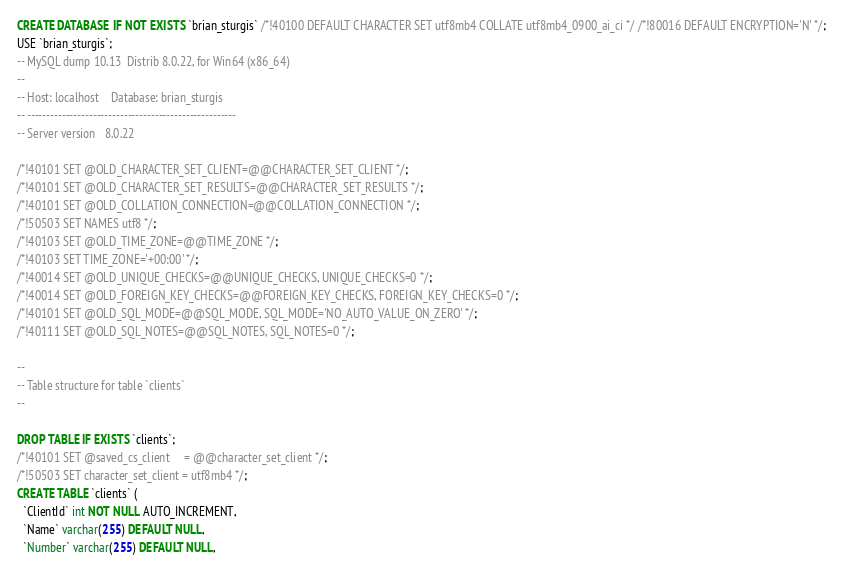Convert code to text. <code><loc_0><loc_0><loc_500><loc_500><_SQL_>CREATE DATABASE  IF NOT EXISTS `brian_sturgis` /*!40100 DEFAULT CHARACTER SET utf8mb4 COLLATE utf8mb4_0900_ai_ci */ /*!80016 DEFAULT ENCRYPTION='N' */;
USE `brian_sturgis`;
-- MySQL dump 10.13  Distrib 8.0.22, for Win64 (x86_64)
--
-- Host: localhost    Database: brian_sturgis
-- ------------------------------------------------------
-- Server version	8.0.22

/*!40101 SET @OLD_CHARACTER_SET_CLIENT=@@CHARACTER_SET_CLIENT */;
/*!40101 SET @OLD_CHARACTER_SET_RESULTS=@@CHARACTER_SET_RESULTS */;
/*!40101 SET @OLD_COLLATION_CONNECTION=@@COLLATION_CONNECTION */;
/*!50503 SET NAMES utf8 */;
/*!40103 SET @OLD_TIME_ZONE=@@TIME_ZONE */;
/*!40103 SET TIME_ZONE='+00:00' */;
/*!40014 SET @OLD_UNIQUE_CHECKS=@@UNIQUE_CHECKS, UNIQUE_CHECKS=0 */;
/*!40014 SET @OLD_FOREIGN_KEY_CHECKS=@@FOREIGN_KEY_CHECKS, FOREIGN_KEY_CHECKS=0 */;
/*!40101 SET @OLD_SQL_MODE=@@SQL_MODE, SQL_MODE='NO_AUTO_VALUE_ON_ZERO' */;
/*!40111 SET @OLD_SQL_NOTES=@@SQL_NOTES, SQL_NOTES=0 */;

--
-- Table structure for table `clients`
--

DROP TABLE IF EXISTS `clients`;
/*!40101 SET @saved_cs_client     = @@character_set_client */;
/*!50503 SET character_set_client = utf8mb4 */;
CREATE TABLE `clients` (
  `ClientId` int NOT NULL AUTO_INCREMENT,
  `Name` varchar(255) DEFAULT NULL,
  `Number` varchar(255) DEFAULT NULL,</code> 